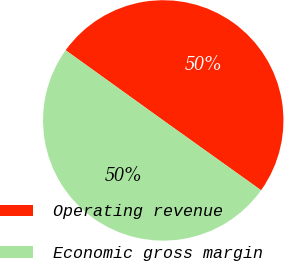<chart> <loc_0><loc_0><loc_500><loc_500><pie_chart><fcel>Operating revenue<fcel>Economic gross margin<nl><fcel>49.95%<fcel>50.05%<nl></chart> 